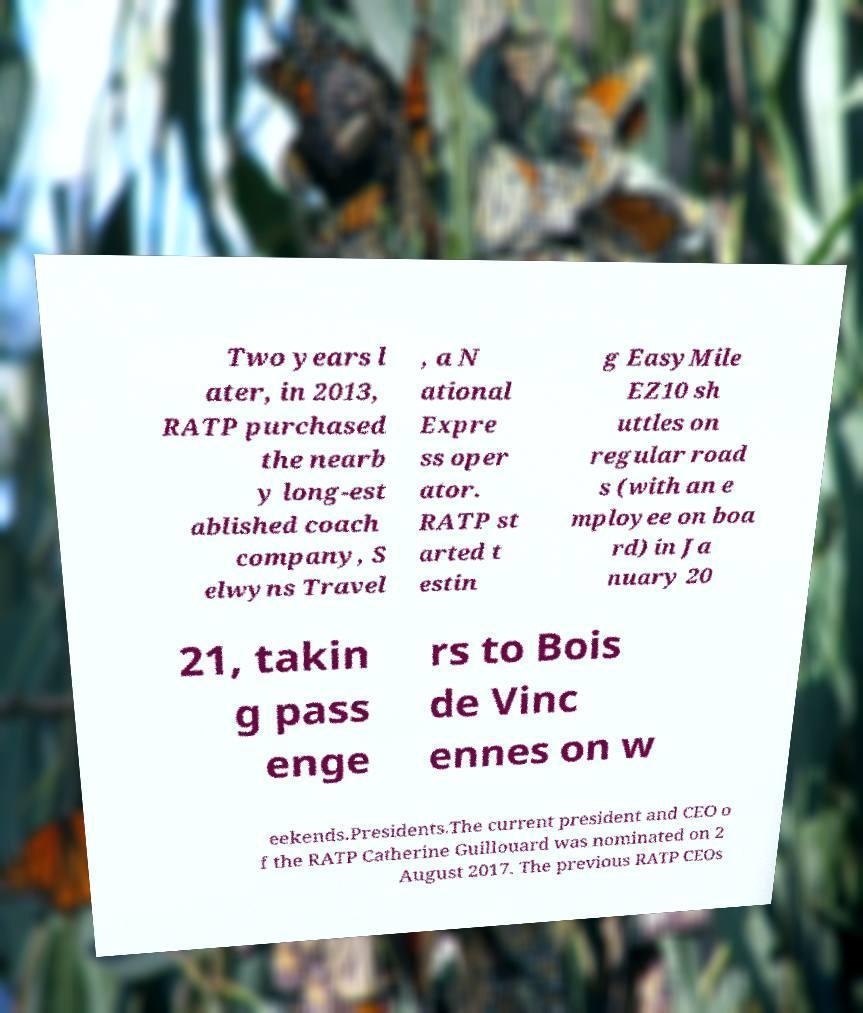Please read and relay the text visible in this image. What does it say? Two years l ater, in 2013, RATP purchased the nearb y long-est ablished coach company, S elwyns Travel , a N ational Expre ss oper ator. RATP st arted t estin g EasyMile EZ10 sh uttles on regular road s (with an e mployee on boa rd) in Ja nuary 20 21, takin g pass enge rs to Bois de Vinc ennes on w eekends.Presidents.The current president and CEO o f the RATP Catherine Guillouard was nominated on 2 August 2017. The previous RATP CEOs 